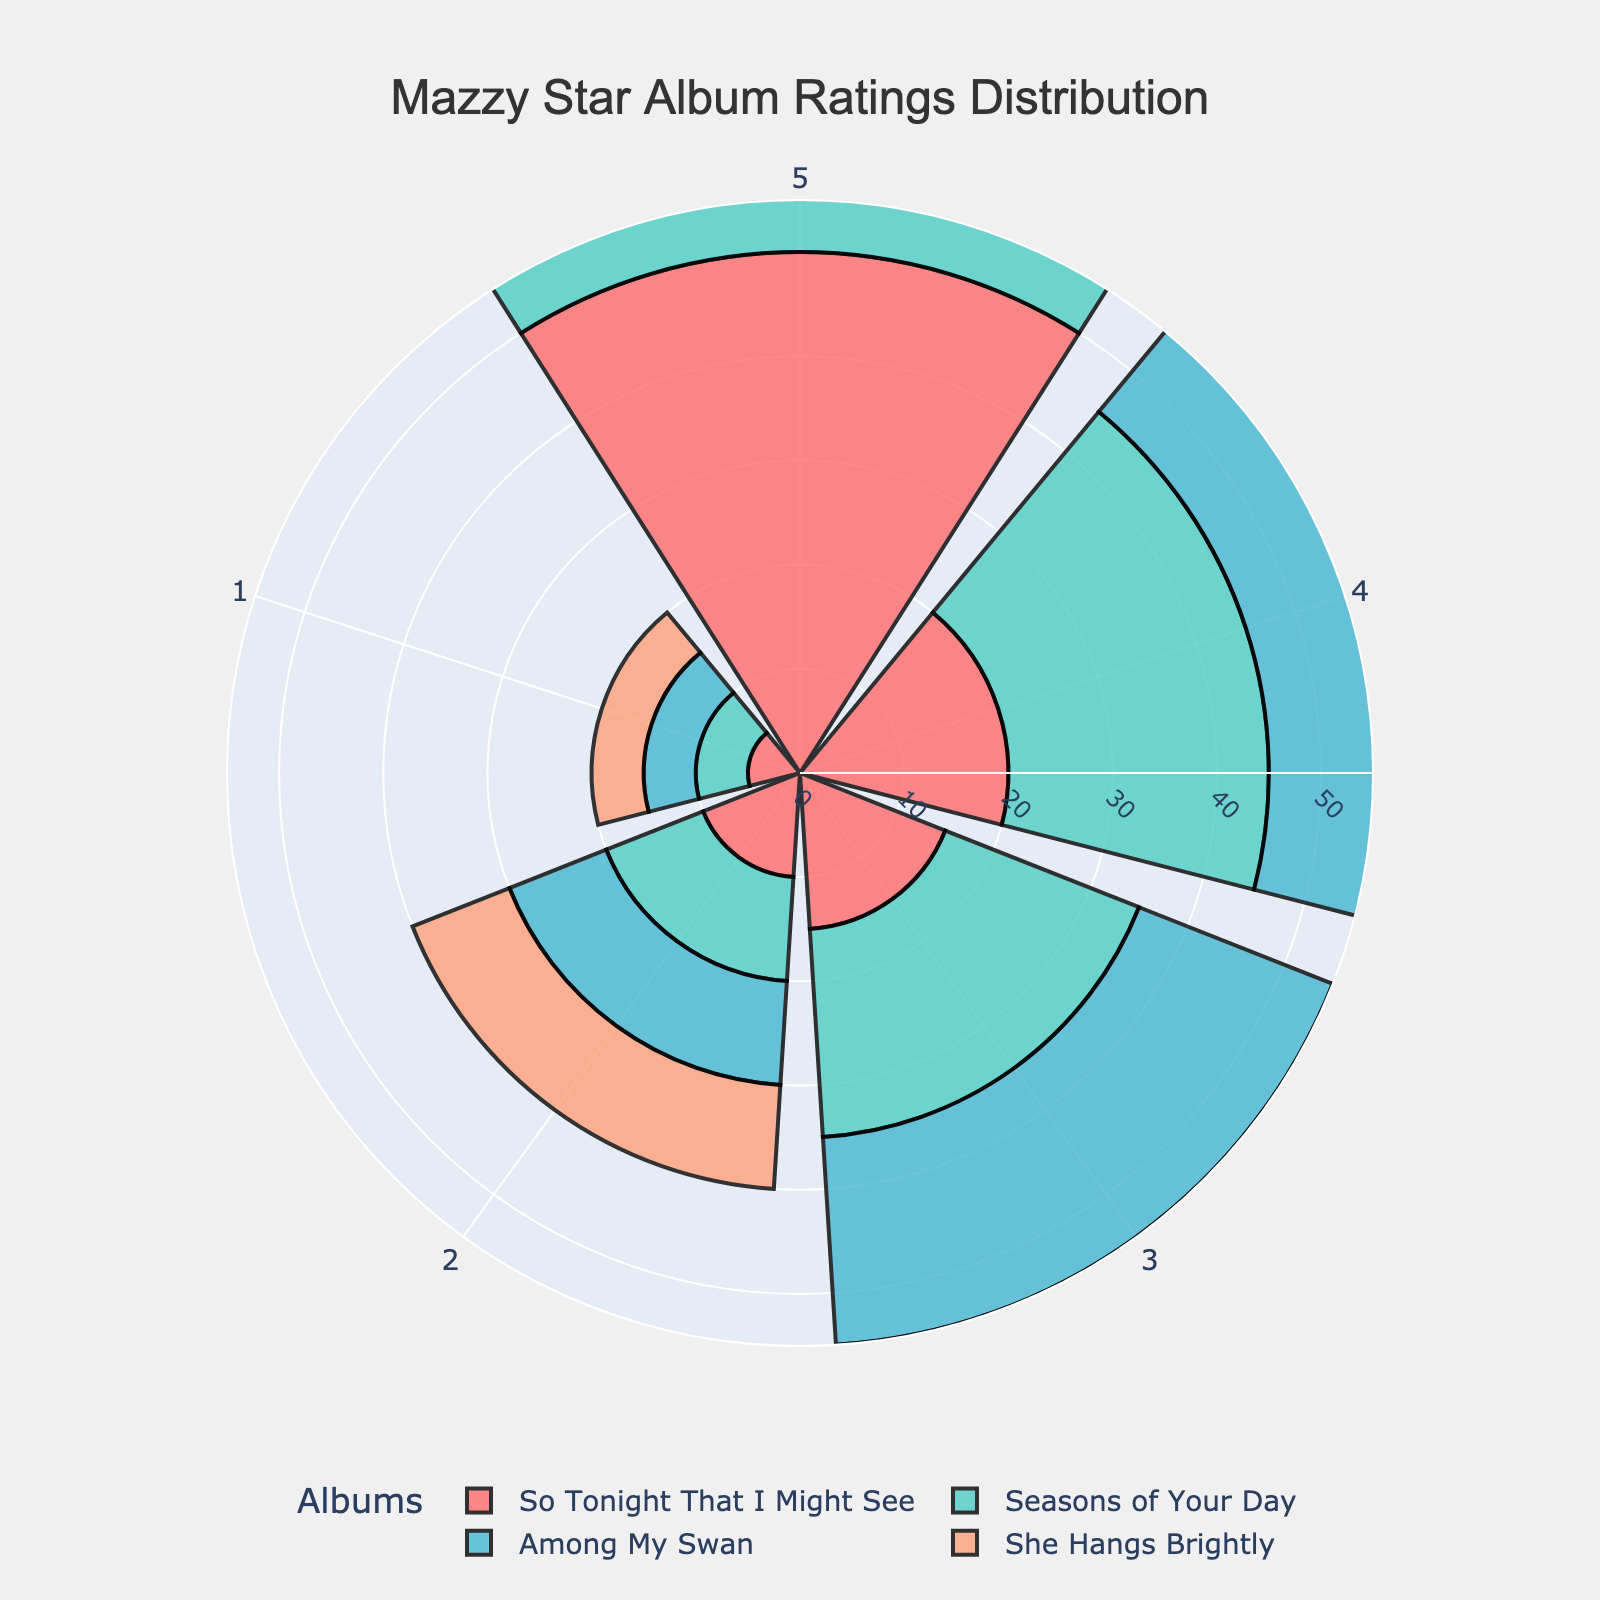What is the title of the figure? The title is typically placed at the top of the figure, and in this case it is mentioned in the layout customization section of the code as "Mazzy Star Album Ratings Distribution".
Answer: Mazzy Star Album Ratings Distribution How many albums are represented in the figure? Each trace in the rose chart represents an album, and the code adds a trace for each album. The provided data lists four albums: "She Hangs Brightly", "So Tonight That I Might See", "Among My Swan", and "Seasons of Your Day".
Answer: 4 Which album has the highest number of 5-star ratings? To determine this, look at the segment corresponding to the 5-star rating for each album. The code for adding traces indicates the counts for each rating. "So Tonight That I Might See" has the largest segment for the 5-star rating with 50 counts.
Answer: So Tonight That I Might See What is the average number of ratings across all albums? Sum the total counts for each album and divide by the number of albums. The total counts are 85, 100, 90, and 95, respectively. Sum these to get 370, and divide by 4.
Answer: 92.5 Which album has the lowest total number of ratings? The total ratings per album are calculated in the code and sorted. "She Hangs Brightly" has the lowest total with 85 ratings.
Answer: She Hangs Brightly Compare the number of 4-star ratings for "She Hangs Brightly" and "Among My Swan". Which album has more? Refer to the segments for the 4-star rating and compare their sizes. "She Hangs Brightly" has 30 while "Among My Swan" also has 30, so they are equal.
Answer: Both are equal What is the combined number of 2-star and 3-star ratings for "Seasons of Your Day"? To find this, sum the counts for the 2-star and 3-star segments for "Seasons of Your Day". The counts are 10 and 20, respectively.
Answer: 30 Which album has the most evenly distributed ratings? Look for the album where the segments for different ratings are relatively similar in size. "Among My Swan" has more evenly distributed ratings compared to the others as its segments sizes (5, 10, 20, 30, 25) are closer.
Answer: Among My Swan What is the total number of 1-star ratings across all albums? Sum the counts for the 1-star rating segment for each album. This includes 5 for each album, so 5 * 4 = 20.
Answer: 20 